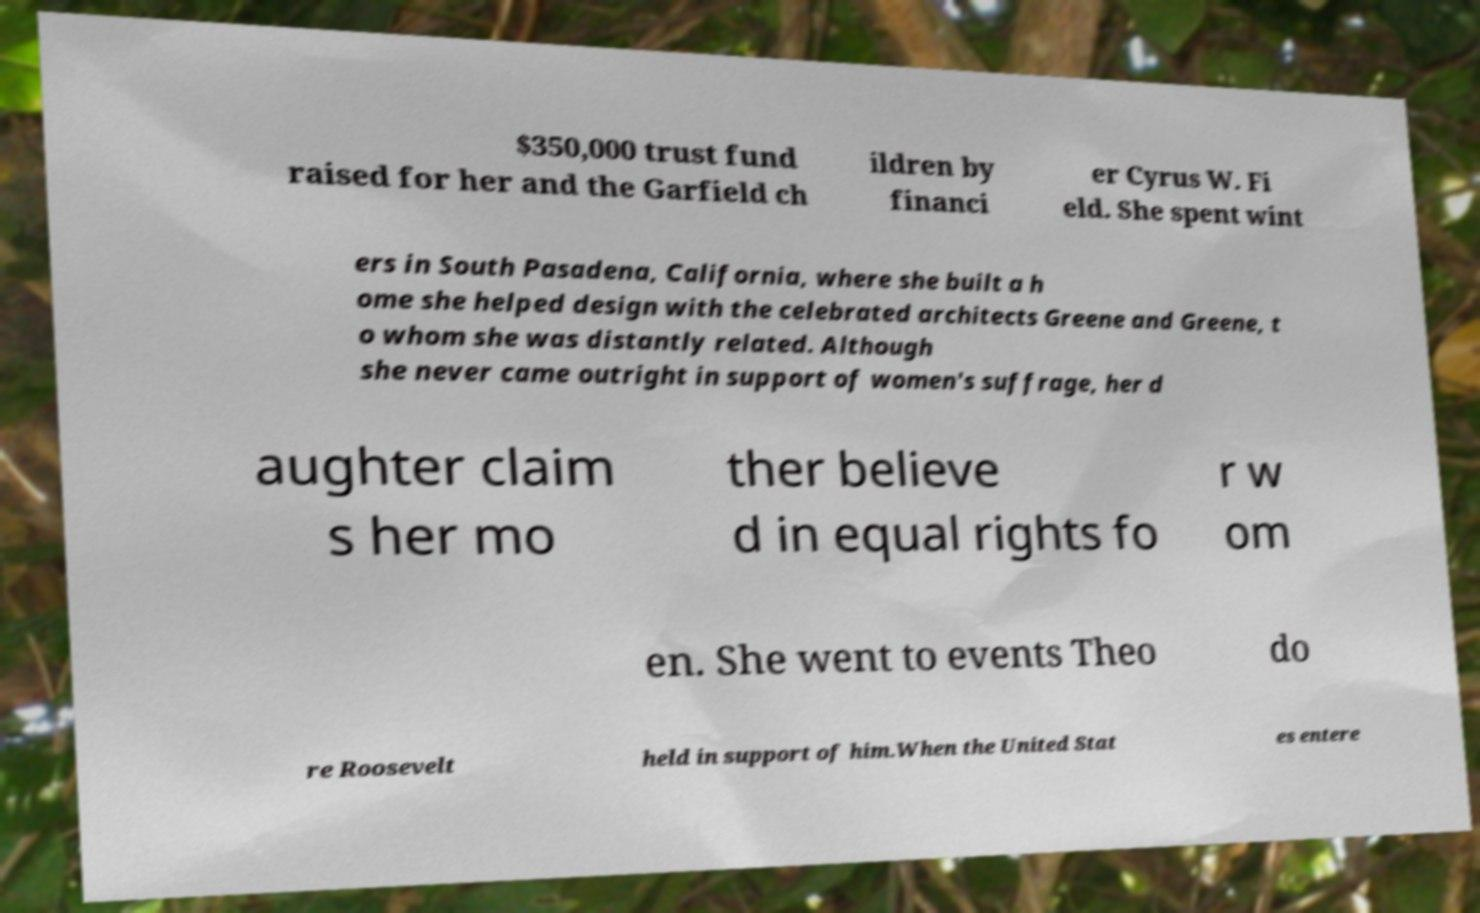I need the written content from this picture converted into text. Can you do that? $350,000 trust fund raised for her and the Garfield ch ildren by financi er Cyrus W. Fi eld. She spent wint ers in South Pasadena, California, where she built a h ome she helped design with the celebrated architects Greene and Greene, t o whom she was distantly related. Although she never came outright in support of women's suffrage, her d aughter claim s her mo ther believe d in equal rights fo r w om en. She went to events Theo do re Roosevelt held in support of him.When the United Stat es entere 